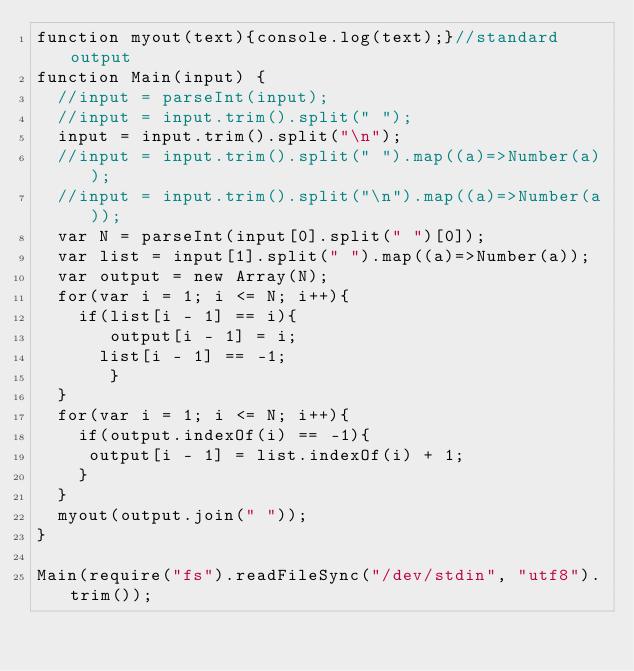Convert code to text. <code><loc_0><loc_0><loc_500><loc_500><_JavaScript_>function myout(text){console.log(text);}//standard output
function Main(input) {
	//input = parseInt(input);
	//input = input.trim().split(" ");
	input = input.trim().split("\n");
	//input = input.trim().split(" ").map((a)=>Number(a));
	//input = input.trim().split("\n").map((a)=>Number(a));
  var N = parseInt(input[0].split(" ")[0]);
  var list = input[1].split(" ").map((a)=>Number(a));
  var output = new Array(N);
  for(var i = 1; i <= N; i++){
    if(list[i - 1] == i){
       output[i - 1] = i;
      list[i - 1] == -1;
       }
  }
  for(var i = 1; i <= N; i++){
    if(output.indexOf(i) == -1){
   	 output[i - 1] = list.indexOf(i) + 1;
  	}
  }
  myout(output.join(" "));
}

Main(require("fs").readFileSync("/dev/stdin", "utf8").trim());
</code> 